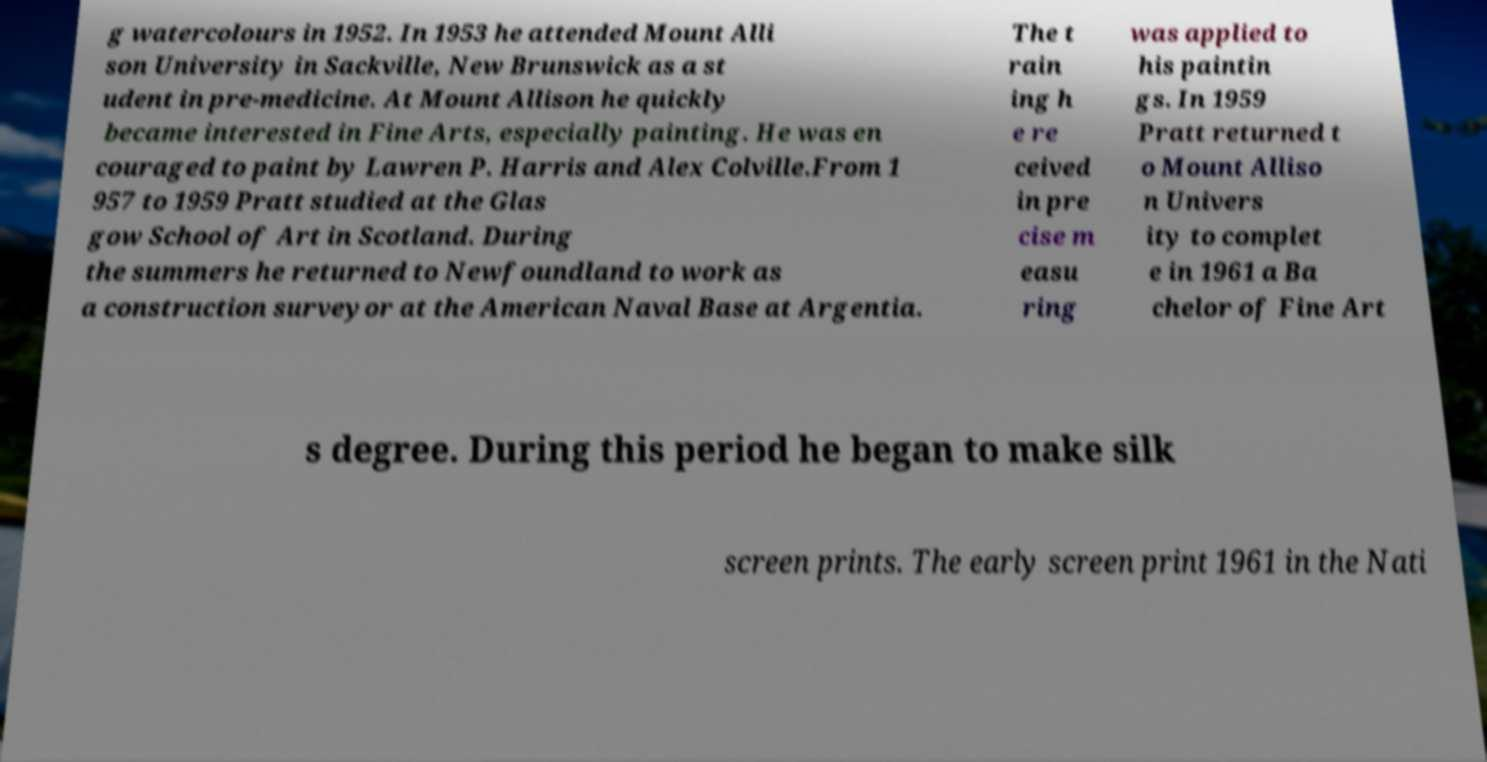What messages or text are displayed in this image? I need them in a readable, typed format. g watercolours in 1952. In 1953 he attended Mount Alli son University in Sackville, New Brunswick as a st udent in pre-medicine. At Mount Allison he quickly became interested in Fine Arts, especially painting. He was en couraged to paint by Lawren P. Harris and Alex Colville.From 1 957 to 1959 Pratt studied at the Glas gow School of Art in Scotland. During the summers he returned to Newfoundland to work as a construction surveyor at the American Naval Base at Argentia. The t rain ing h e re ceived in pre cise m easu ring was applied to his paintin gs. In 1959 Pratt returned t o Mount Alliso n Univers ity to complet e in 1961 a Ba chelor of Fine Art s degree. During this period he began to make silk screen prints. The early screen print 1961 in the Nati 